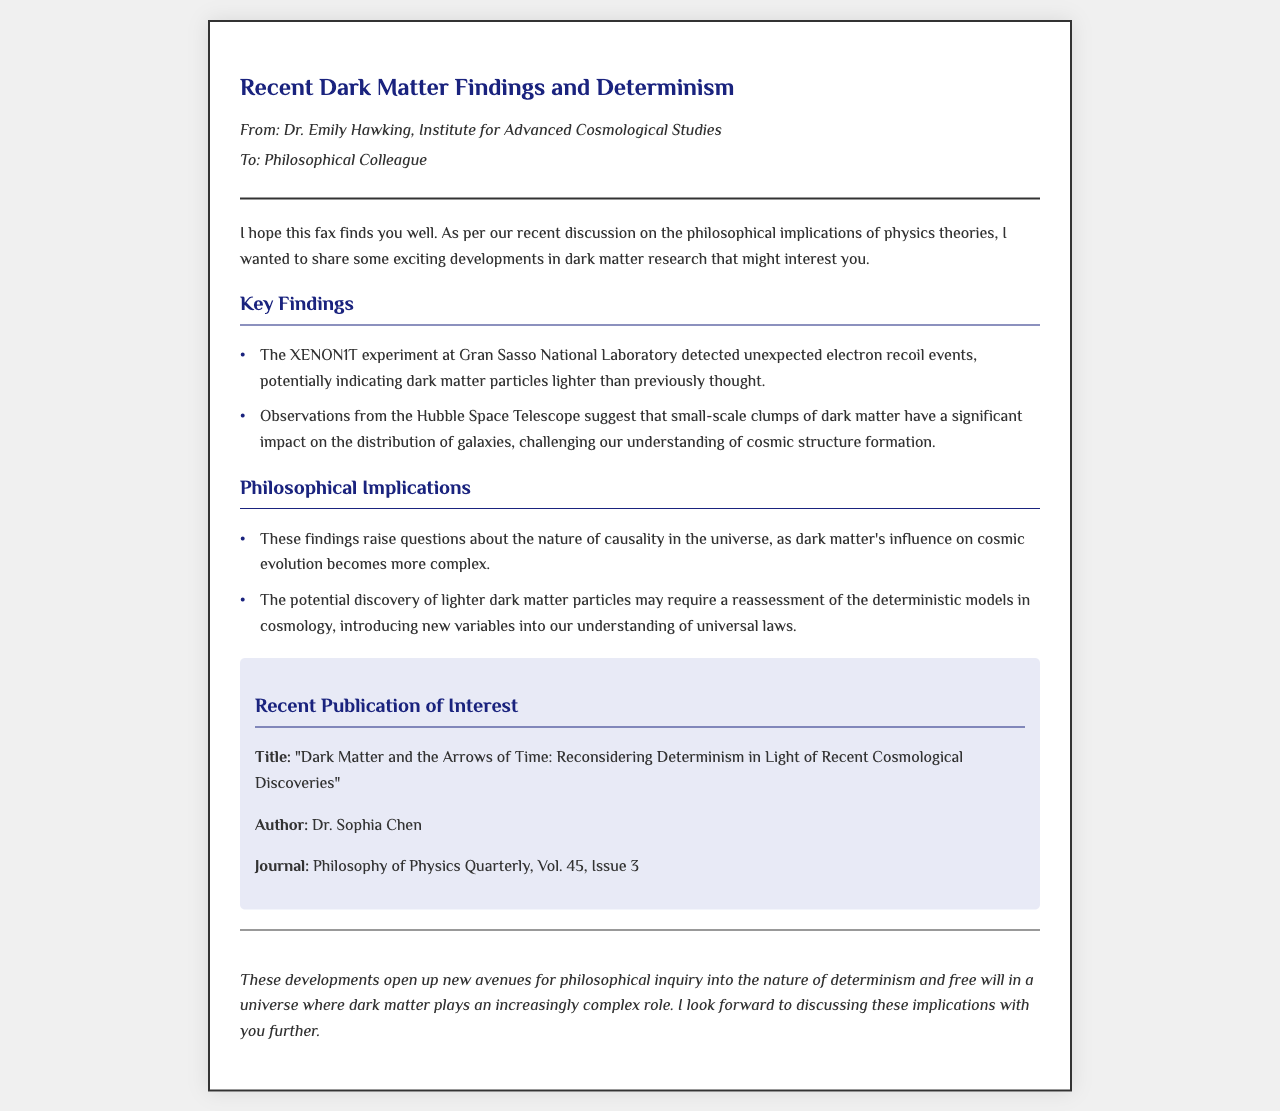What recent experiment detected unexpected electron recoil events? The document mentions the XENON1T experiment at Gran Sasso National Laboratory detecting unexpected electron recoil events.
Answer: XENON1T What does the Hubble Space Telescope's observations suggest? According to the document, observations from the Hubble Space Telescope suggest that small-scale clumps of dark matter impact the distribution of galaxies.
Answer: Small-scale clumps of dark matter Who authored the publication mentioned in the fax? The document lists Dr. Sophia Chen as the author of the publication.
Answer: Dr. Sophia Chen What is the title of the recent publication of interest? The document indicates that the title of the publication is "Dark Matter and the Arrows of Time: Reconsidering Determinism in Light of Recent Cosmological Discoveries."
Answer: Dark Matter and the Arrows of Time: Reconsidering Determinism in Light of Recent Cosmological Discoveries What is one philosophical implication of the key findings? The document states that one philosophical implication is that the findings raise questions about the nature of causality in the universe.
Answer: Nature of causality What volume and issue number is the journal where the publication appeared? The document notes that the publication appeared in Philosophy of Physics Quarterly, Vol. 45, Issue 3.
Answer: Vol. 45, Issue 3 What is the conclusion made in the fax regarding dark matter? The document concludes that developments open new avenues for philosophical inquiry into determinism and free will in relation to dark matter.
Answer: New avenues for philosophical inquiry 